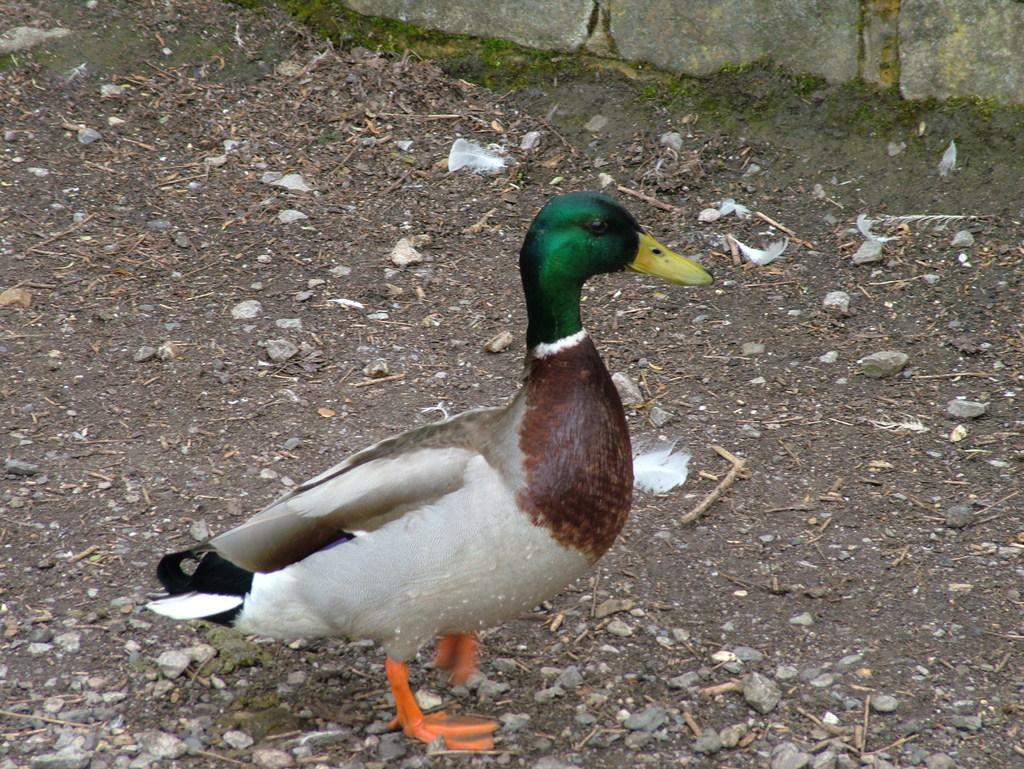What animal is present in the image? There is a duck in the image. Where is the duck located in the image? The duck is standing in the center of the image. What surface is the duck standing on? The duck is on the ground in the image. What can be seen in the background of the image? There is a wall visible at the top of the image. What type of material is present on the ground in the image? There are stones on the ground in the image. What type of pot can be seen in the image? There is no pot present in the image. Can you describe the veins visible on the duck's wings? There are no veins visible on the duck's wings in the image, as it is a photograph and not a detailed illustration. 